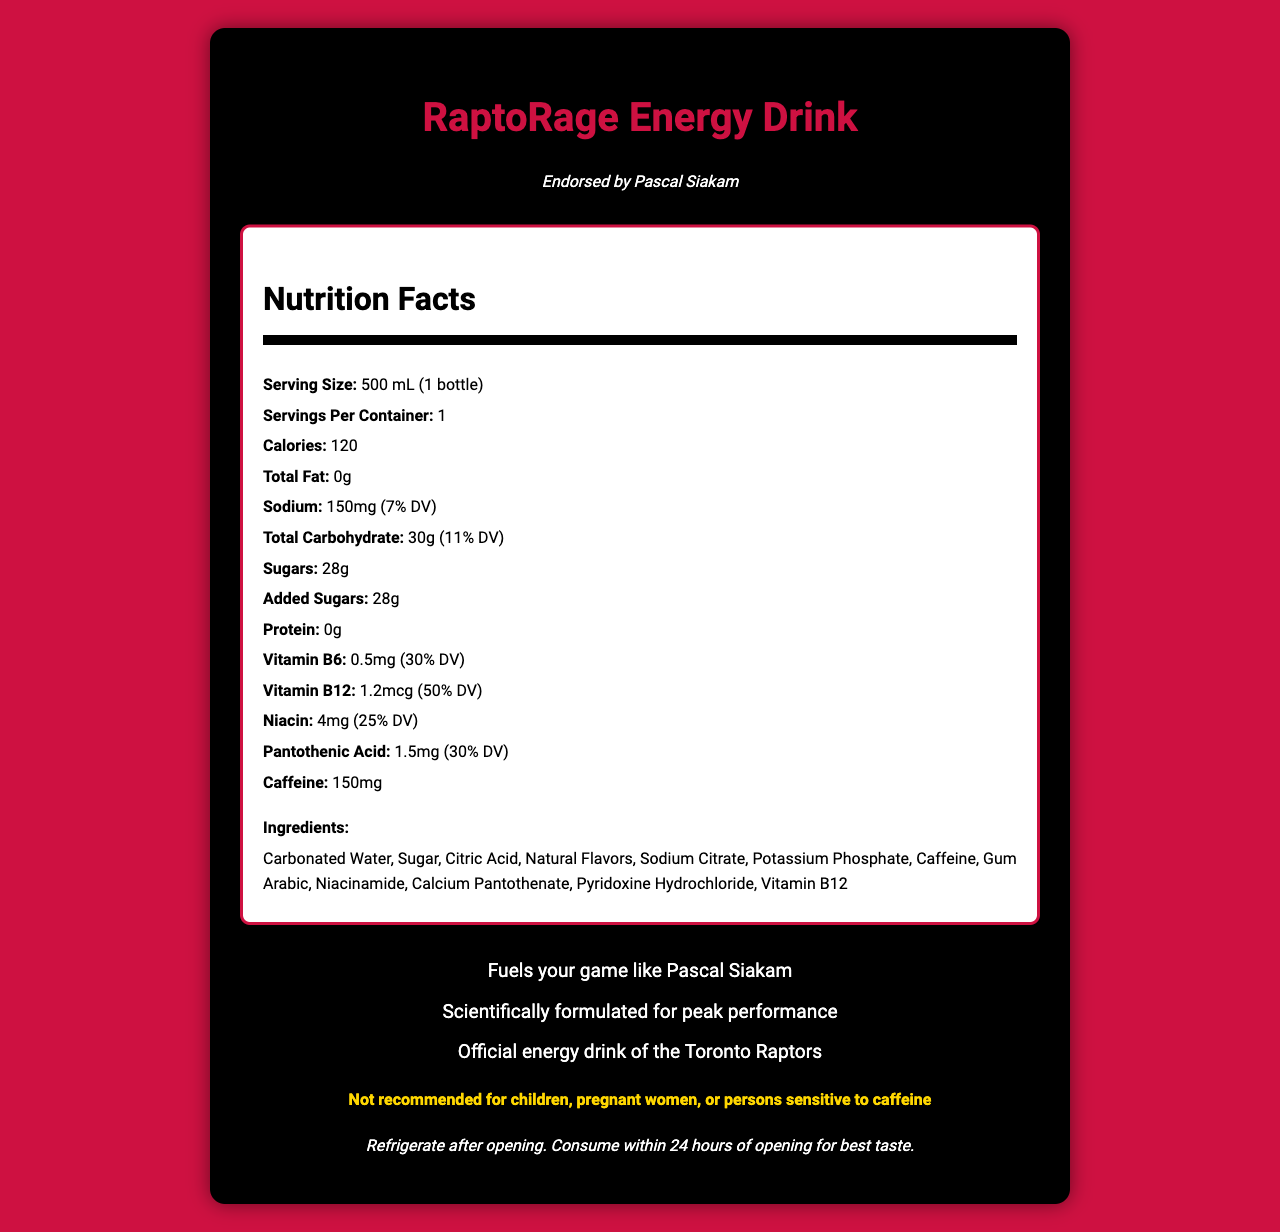what is the serving size of RaptoRage Energy Drink? The serving size is mentioned in the document under the Nutrition Facts section.
Answer: 500 mL (1 bottle) how many grams of sugars are in one serving? The amount of sugars per serving is specified directly in the Nutrition Facts section.
Answer: 28g what is the amount of caffeine in RaptoRage Energy Drink? The amount of caffeine is listed in the Nutrition Facts section.
Answer: 150mg how should the drink be stored after opening? The storage instructions are provided towards the end of the document.
Answer: Refrigerate after opening. Consume within 24 hours of opening for best taste. what allergens might be present in RaptoRage Energy Drink? The allergen information is clearly stated in the document.
Answer: Manufactured in a facility that also processes soy and milk products who endorses RaptoRage Energy Drink? The endorsement by Pascal Siakam is highlighted at the top of the document.
Answer: Pascal Siakam how many calories are in one serving? The calories per serving are mentioned in the Nutrition Facts section.
Answer: 120 what is the percentage Daily Value (DV) of Vitamin B12? The percentage Daily Value of Vitamin B12 is specified in the Nutrition Facts section.
Answer: 50% which of the following ingredients is not found in RaptoRage Energy Drink? A. Carbonated Water B. High Fructose Corn Syrup C. Citric Acid High Fructose Corn Syrup is not listed among the ingredients.
Answer: B which dietary claim is NOT made about RaptoRage Energy Drink? A. Gluten-Free B. Vegan C. Low in Sodium D. No Artificial Colors The dietary claims "Gluten-Free," "Vegan," and "No Artificial Colors" are mentioned, but "Low in Sodium" is not.
Answer: C is RaptoRage Energy Drink suitable for children? The warning statement advises that the drink is not recommended for children.
Answer: No summarize the main idea of the document. The document aims to provide comprehensive information about RaptoRage Energy Drink, including its nutritional profile, ingredients, endorsements, marketing claims, storage instructions, and warnings.
Answer: RaptoRage Energy Drink is a sports drink endorsed by Pascal Siakam. It provides nutrition facts, dietary, and allergen information. It highlights its performance-boosting claims and is marketed as the official energy drink of the Toronto Raptors. The document also provides storage instructions and a warning for specific groups. what is the total fat content in a serving? The total fat content is listed as 0g in the Nutrition Facts section.
Answer: 0g what percentage of the Daily Value does sodium represent? The document states that the amount of sodium represents 7% of the Daily Value.
Answer: 7% how many servings are in one container of RaptoRage Energy Drink? The number of servings per container is clearly stated as 1.
Answer: 1 why is the beverage not recommended for children, pregnant women, or persons sensitive to caffeine? While the document provides a warning, it does not specify the reasons behind these recommendations.
Answer: Not enough information 